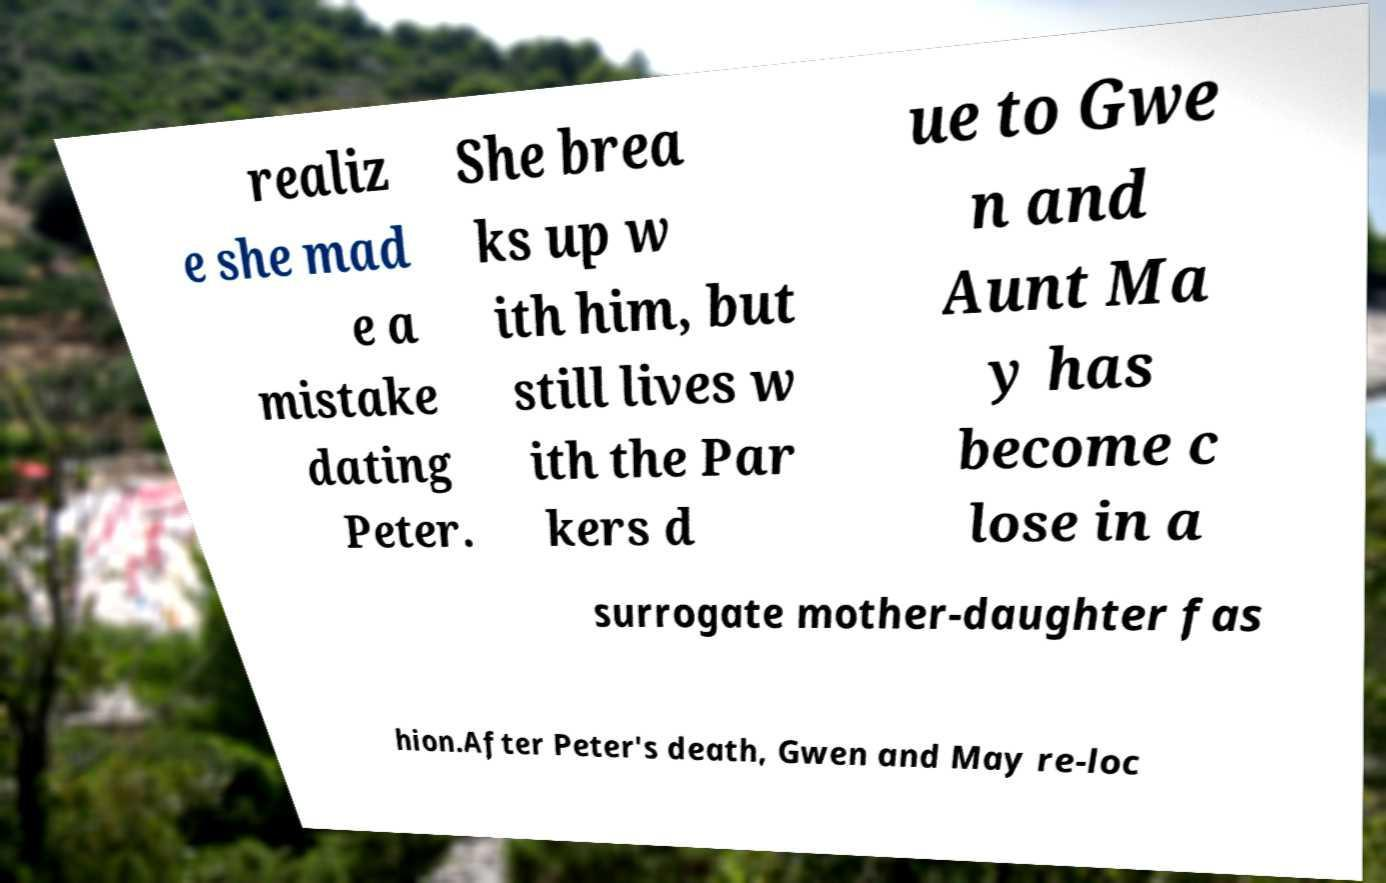Can you read and provide the text displayed in the image?This photo seems to have some interesting text. Can you extract and type it out for me? realiz e she mad e a mistake dating Peter. She brea ks up w ith him, but still lives w ith the Par kers d ue to Gwe n and Aunt Ma y has become c lose in a surrogate mother-daughter fas hion.After Peter's death, Gwen and May re-loc 